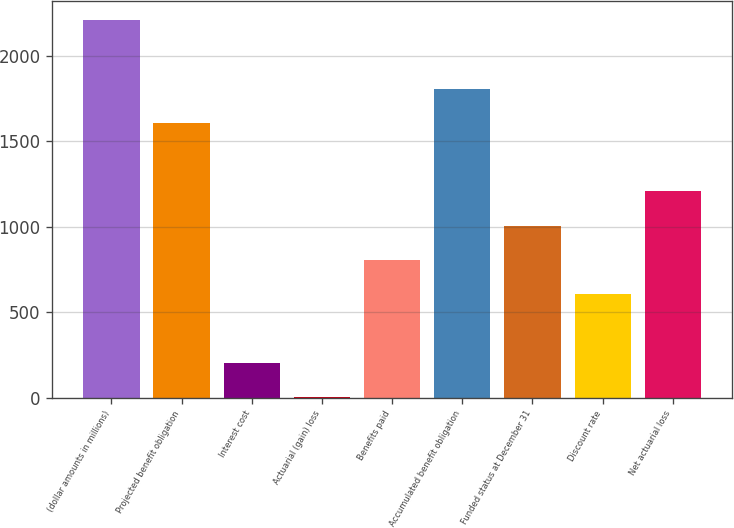Convert chart. <chart><loc_0><loc_0><loc_500><loc_500><bar_chart><fcel>(dollar amounts in millions)<fcel>Projected benefit obligation<fcel>Interest cost<fcel>Actuarial (gain) loss<fcel>Benefits paid<fcel>Accumulated benefit obligation<fcel>Funded status at December 31<fcel>Discount rate<fcel>Net actuarial loss<nl><fcel>2211.9<fcel>1609.2<fcel>202.9<fcel>2<fcel>805.6<fcel>1810.1<fcel>1006.5<fcel>604.7<fcel>1207.4<nl></chart> 